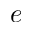Convert formula to latex. <formula><loc_0><loc_0><loc_500><loc_500>e</formula> 